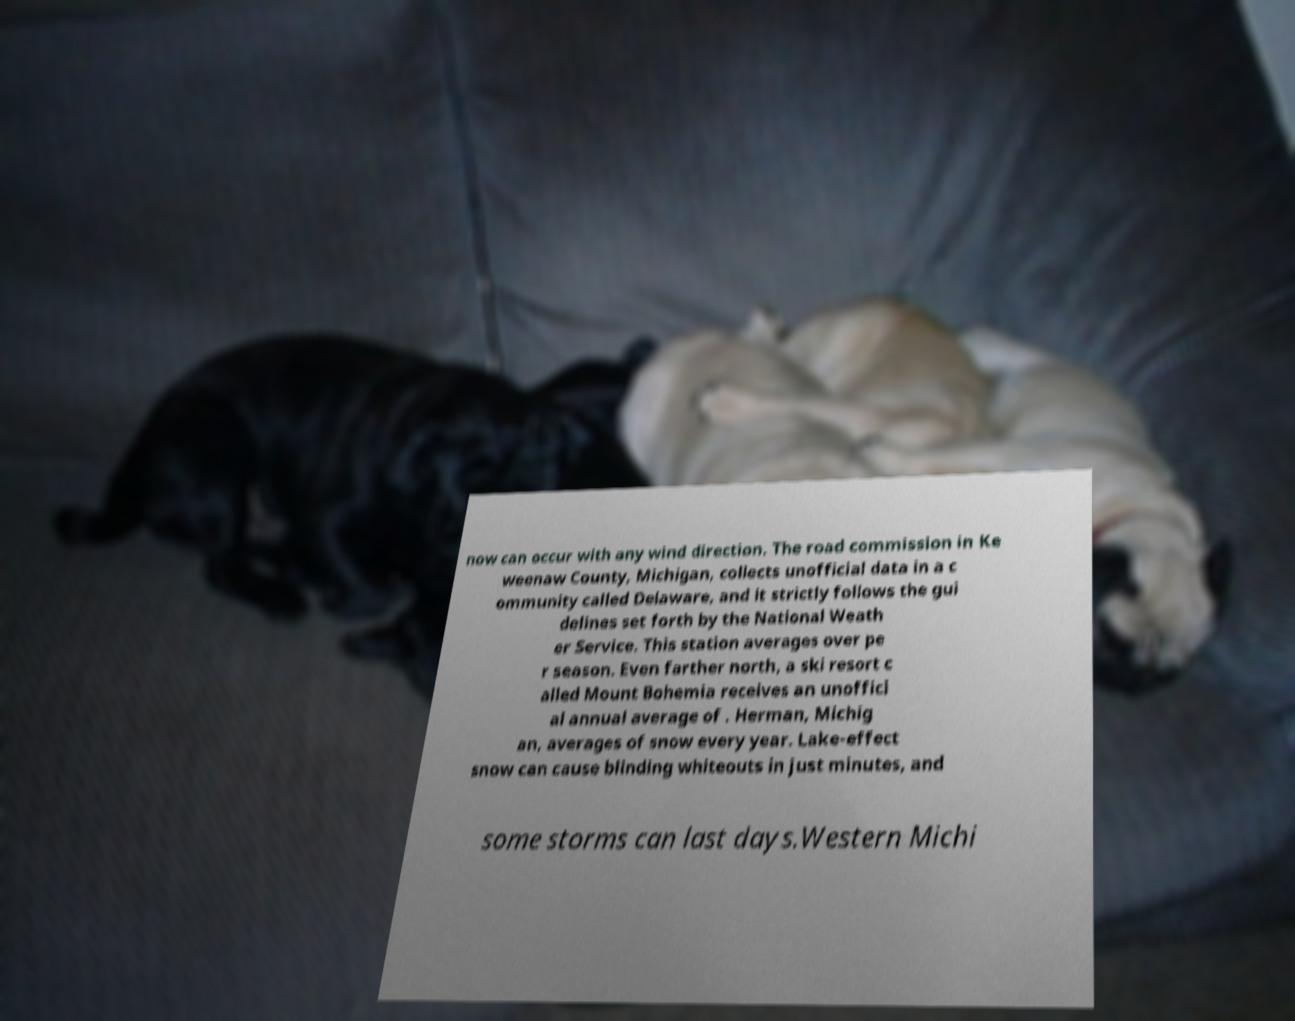Could you extract and type out the text from this image? now can occur with any wind direction. The road commission in Ke weenaw County, Michigan, collects unofficial data in a c ommunity called Delaware, and it strictly follows the gui delines set forth by the National Weath er Service. This station averages over pe r season. Even farther north, a ski resort c alled Mount Bohemia receives an unoffici al annual average of . Herman, Michig an, averages of snow every year. Lake-effect snow can cause blinding whiteouts in just minutes, and some storms can last days.Western Michi 